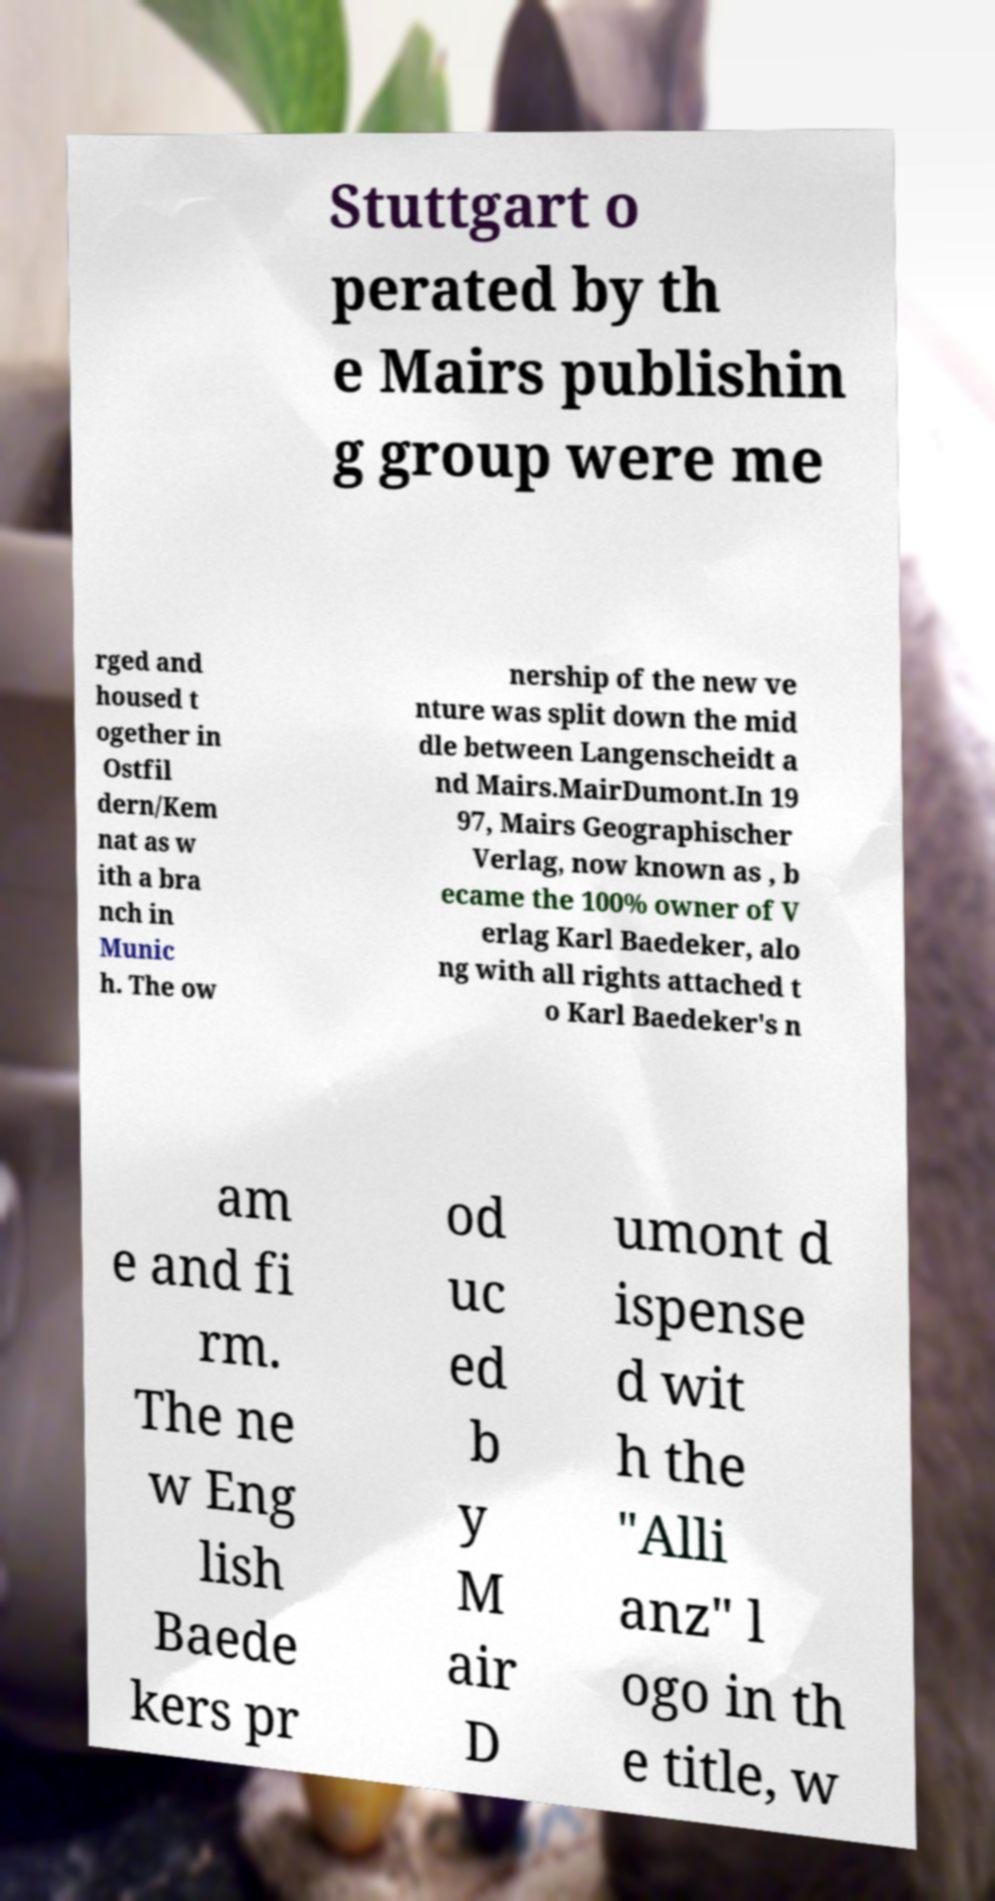Please identify and transcribe the text found in this image. Stuttgart o perated by th e Mairs publishin g group were me rged and housed t ogether in Ostfil dern/Kem nat as w ith a bra nch in Munic h. The ow nership of the new ve nture was split down the mid dle between Langenscheidt a nd Mairs.MairDumont.In 19 97, Mairs Geographischer Verlag, now known as , b ecame the 100% owner of V erlag Karl Baedeker, alo ng with all rights attached t o Karl Baedeker's n am e and fi rm. The ne w Eng lish Baede kers pr od uc ed b y M air D umont d ispense d wit h the "Alli anz" l ogo in th e title, w 